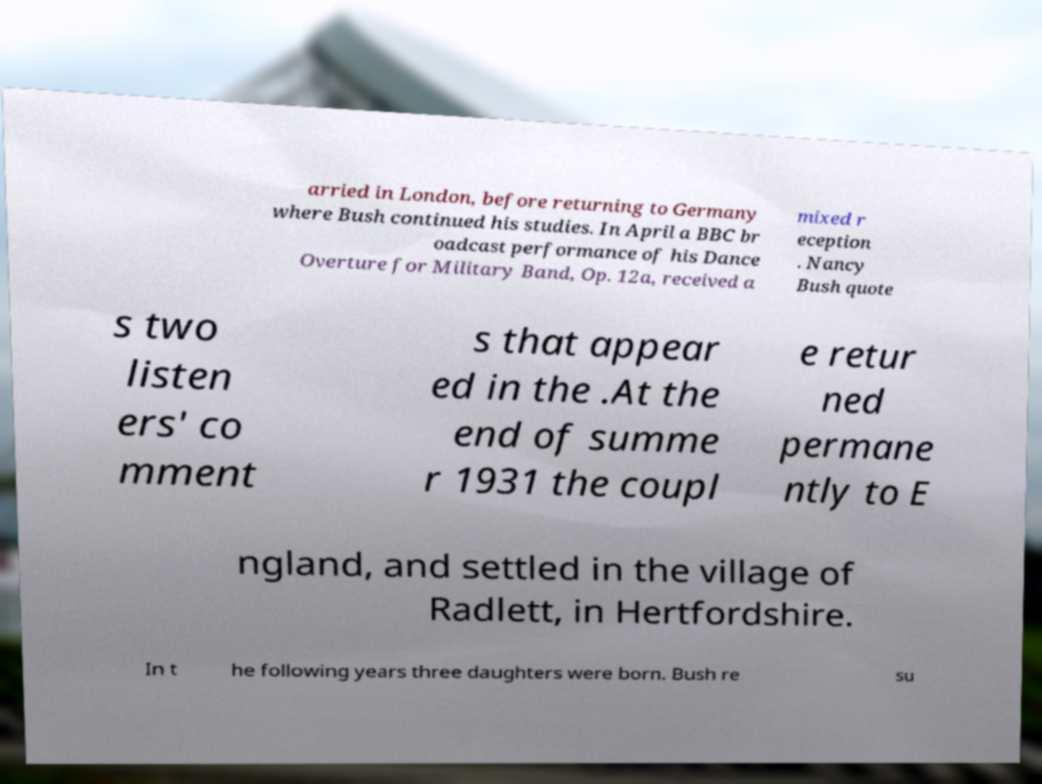Can you accurately transcribe the text from the provided image for me? arried in London, before returning to Germany where Bush continued his studies. In April a BBC br oadcast performance of his Dance Overture for Military Band, Op. 12a, received a mixed r eception . Nancy Bush quote s two listen ers' co mment s that appear ed in the .At the end of summe r 1931 the coupl e retur ned permane ntly to E ngland, and settled in the village of Radlett, in Hertfordshire. In t he following years three daughters were born. Bush re su 